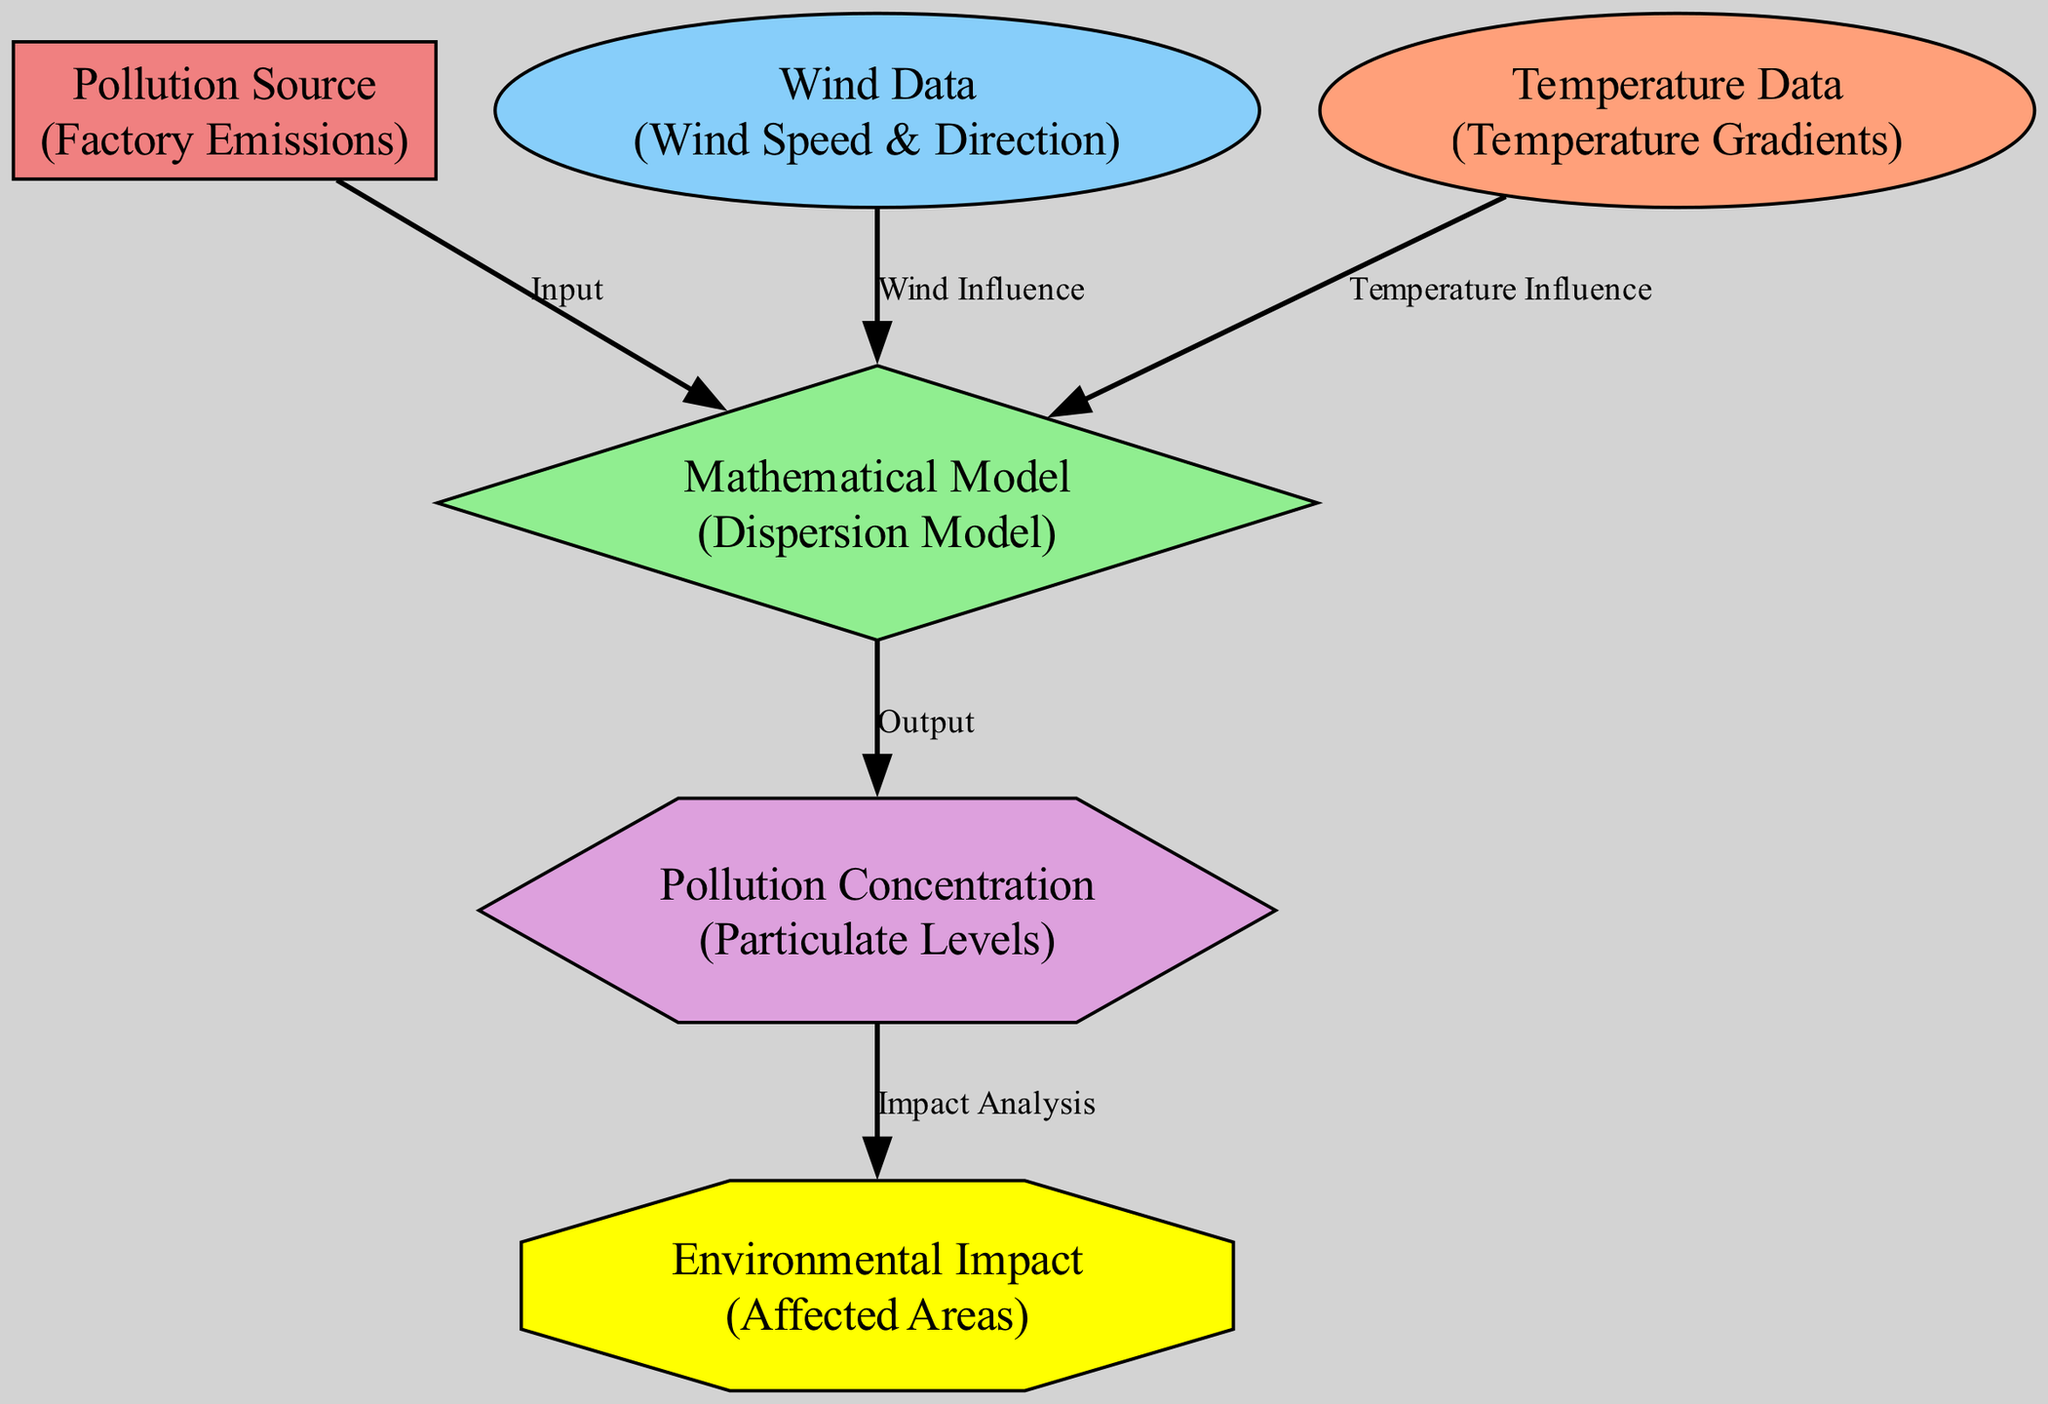What is the pollution source identified in the diagram? The diagram identifies "Factory Emissions" as the pollution source. This is represented as the first node labeled "Pollution Source".
Answer: Factory Emissions How many edges are present in the diagram? The diagram contains five edges which are the connections between nodes that represent the flow of information. By counting the relationships drawn between the nodes, we find there are five edges.
Answer: 5 What is the role of the Wind Data in the dispersion process? Wind Data influences the Mathematical Model, specifically labeled as "Wind Influence". This indicates that wind conditions are taken into account within the dispersion framework provided by the model.
Answer: Wind Influence Which node receives the output from the Mathematical Model? The Pollution Concentration node receives the output from the Mathematical Model, as indicated by the directional edge labeled "Output" connecting these two nodes in the diagram.
Answer: Pollution Concentration To which node does the Pollution Concentration contribute for analysis? Pollution Concentration contributes to the Environmental Impact node for analysis, as represented by the edge labeled "Impact Analysis" leading from Pollution Concentration to Environmental Impact.
Answer: Environmental Impact What type of node is represented by the Mathematical Model? The Mathematical Model is represented as a diamond-shaped node in the diagram, indicating it serves a distinct function within the flow of information regarding pollution dispersion.
Answer: Diamond Which factor has a direct influence on the dispersion model alongside Wind Data? Temperature Data also has a direct influence on the Mathematical Model, as indicated by the edge labeled "Temperature Influence" that connects Temperature Data to the Mathematical Model alongside Wind Data.
Answer: Temperature Data How does the Pollution Source relate to the Mathematical Model? The Pollution Source, identified as "Factory Emissions", provides input to the Mathematical Model, with an edge labeled "Input" showing this relationship in the diagram.
Answer: Input What are the affected areas determined by? The affected areas are determined by the Environmental Impact node, which is the final output of the analysis process depicted in the diagram.
Answer: Environmental Impact 